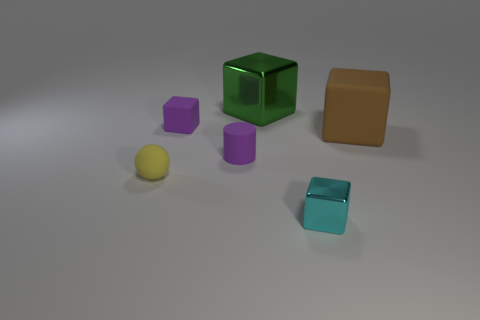What is the size of the shiny cube that is to the left of the small block in front of the ball?
Make the answer very short. Large. Are there an equal number of shiny objects behind the big rubber thing and green metal things to the left of the tiny purple cube?
Provide a succinct answer. No. Is there a tiny cylinder behind the block in front of the large brown matte cube?
Provide a succinct answer. Yes. What number of metallic things are to the left of the metal thing that is in front of the tiny yellow thing that is in front of the big green metal cube?
Provide a short and direct response. 1. Are there fewer purple cylinders than small red objects?
Offer a terse response. No. Do the matte object to the right of the tiny cyan block and the green thing that is behind the ball have the same shape?
Offer a very short reply. Yes. What color is the big rubber block?
Your response must be concise. Brown. How many matte things are red blocks or small purple cubes?
Provide a succinct answer. 1. What color is the other large metallic thing that is the same shape as the cyan object?
Your answer should be very brief. Green. Are any large brown things visible?
Offer a terse response. Yes. 